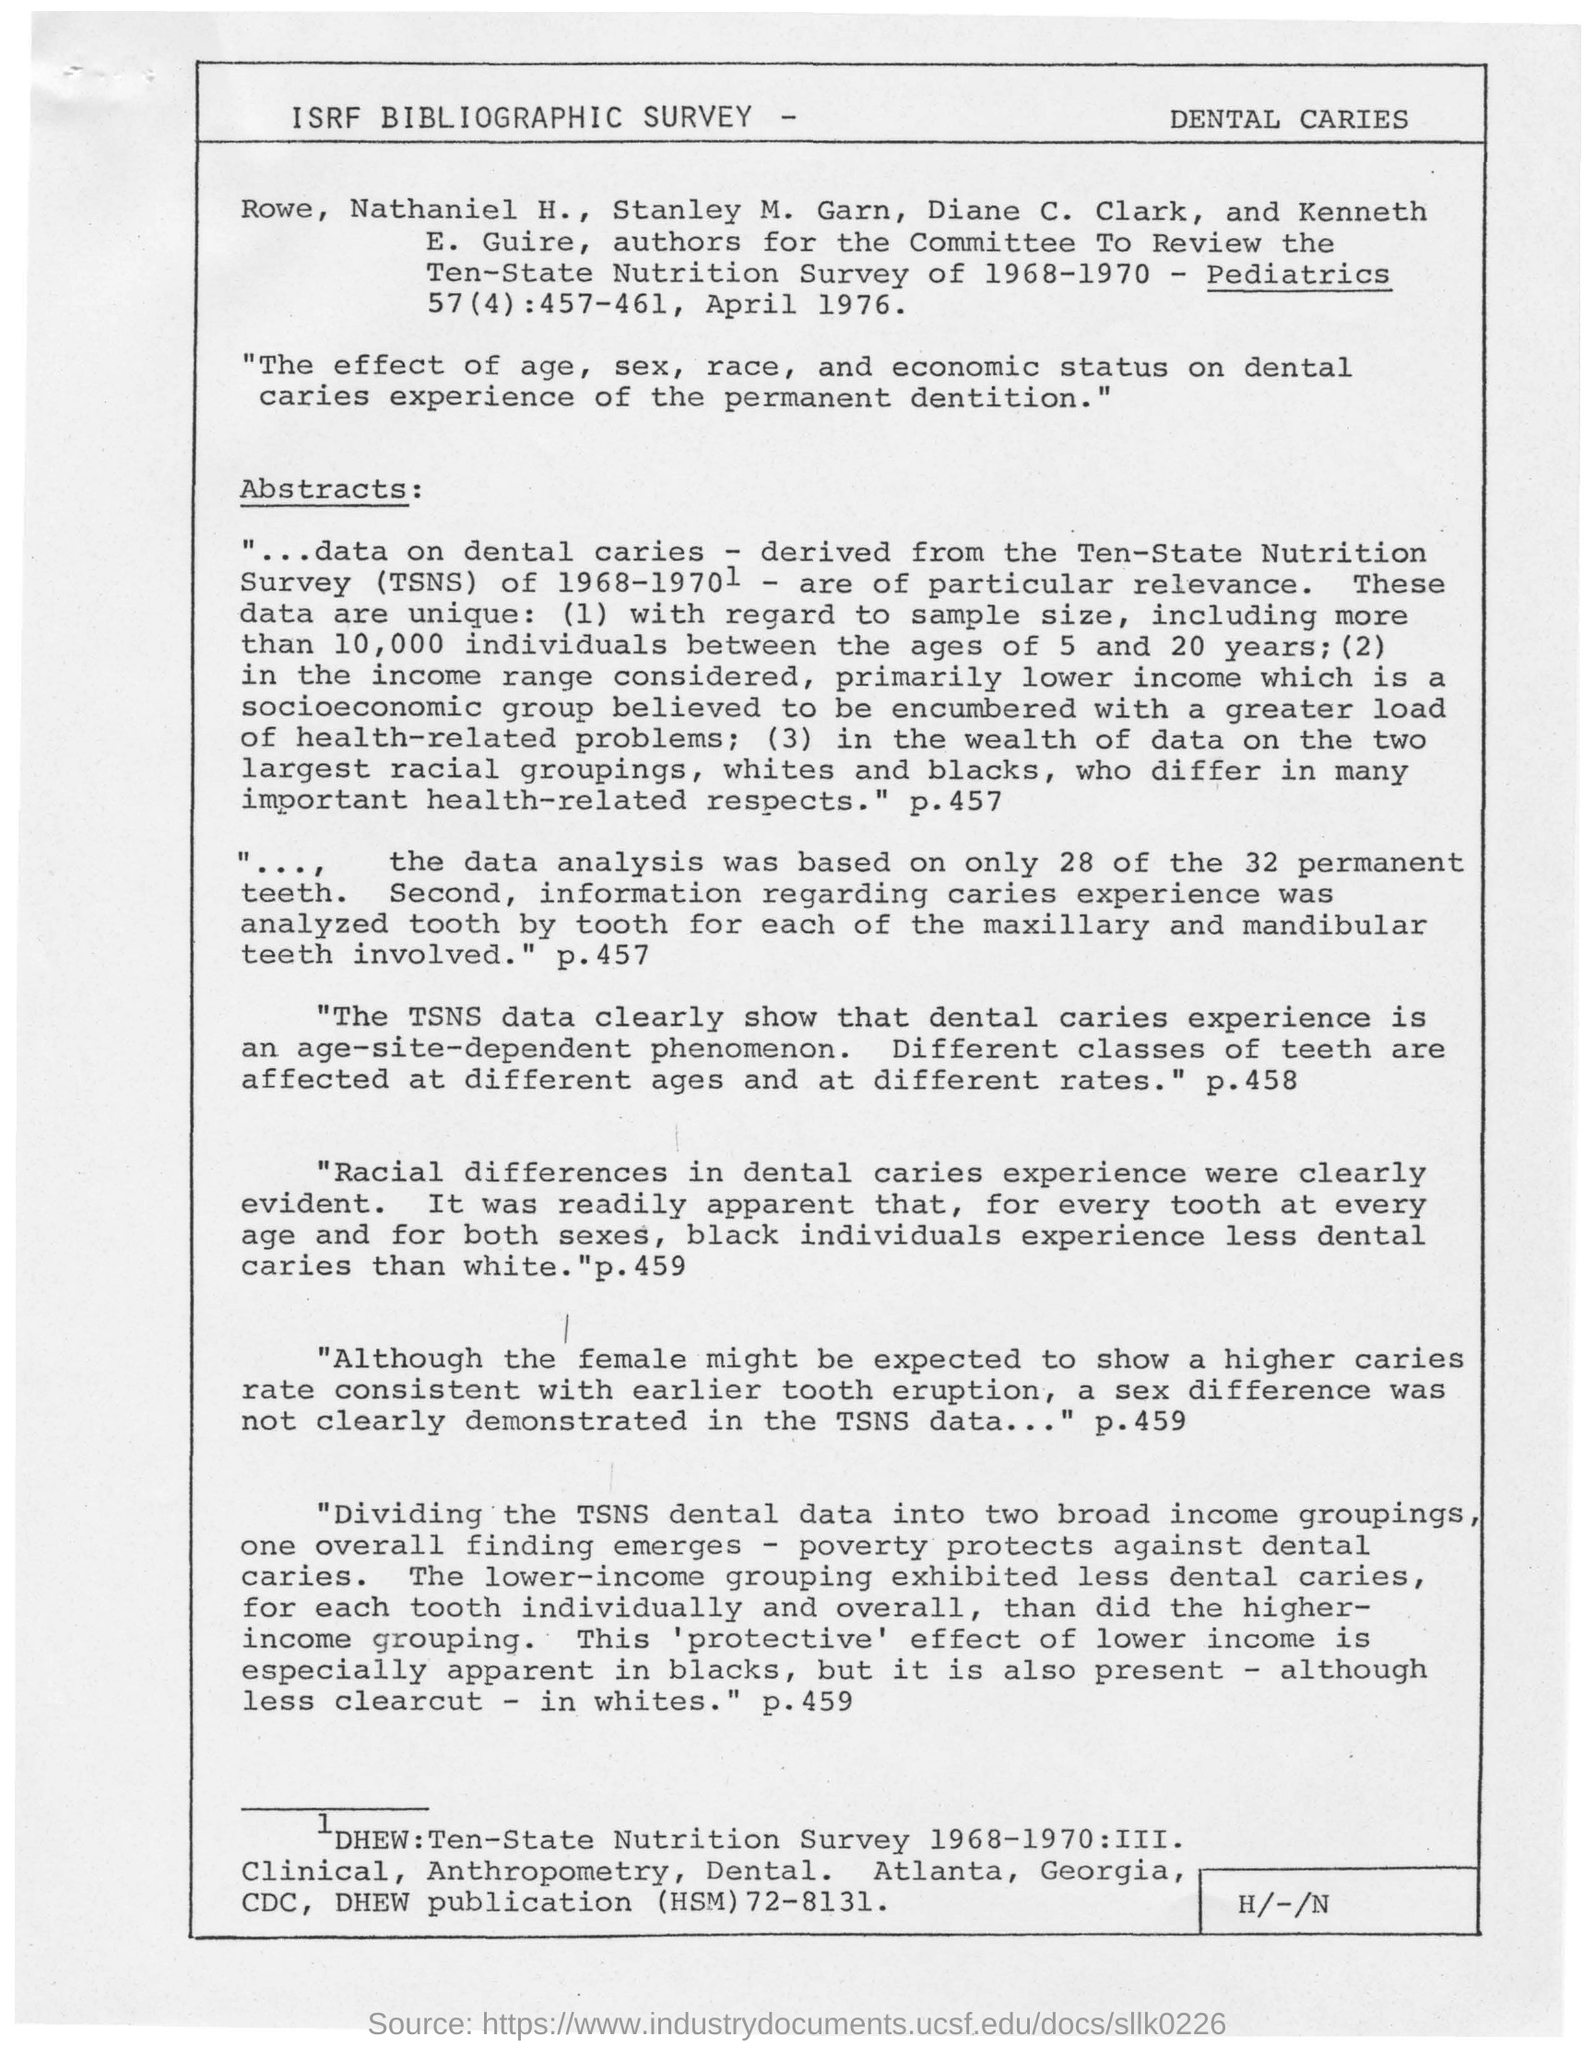Specify some key components in this picture. The study found clear differences in dental caries experience between racial groups, which were evident in the data. The heading of this document is the ISRF bibliographic survey. 